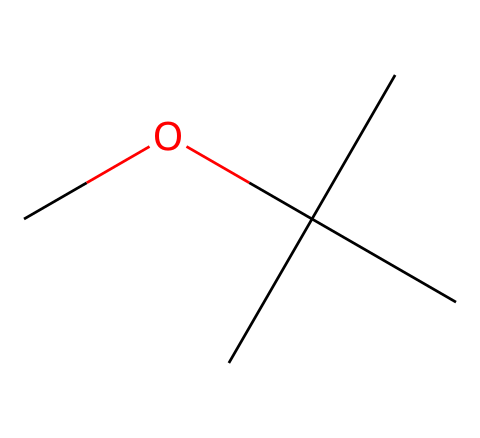What is the molecular formula of this compound? The SMILES representation translates to a molecular formula by counting each type of atom present. In this case, there are 5 carbon (C) atoms, 12 hydrogen (H) atoms, and 1 oxygen (O) atom, leading to a molecular formula of C5H12O.
Answer: C5H12O How many carbon atoms are in this molecule? The SMILES string contains multiple 'C' characters; specifically, there are 5 'C' atoms present in the representation, indicating that the molecule consists of five carbon atoms.
Answer: 5 What type of compound is methyl tert-butyl ether? This compound belongs to a class of compounds known as ethers, characterized by the presence of an oxygen atom connected to two carbon-containing groups. The structural arrangement in the SMILES confirms this classification.
Answer: ether What is the primary functional group in this molecule? The primary functional group in ethers is the oxygen atom bonded to two carbon atoms. In the SMILES representation, there is one such oxygen, indicating that it serves as the functional group of this compound.
Answer: ether Can this compound be classified as branched or straight-chain? The structure exhibits a branched arrangement due to the tert-butyl group, which is indicated by the grouping of carbon atoms around the central carbon atom bonded to the oxygen. This shows that the compound has a branching structure.
Answer: branched What is the total number of hydrogen atoms in this compound? By analyzing the molecular formula derived from the SMILES (C5H12O), we see that the total number of hydrogen atoms is 12, which is simply stated in the formula as part of the molecule’s composition.
Answer: 12 